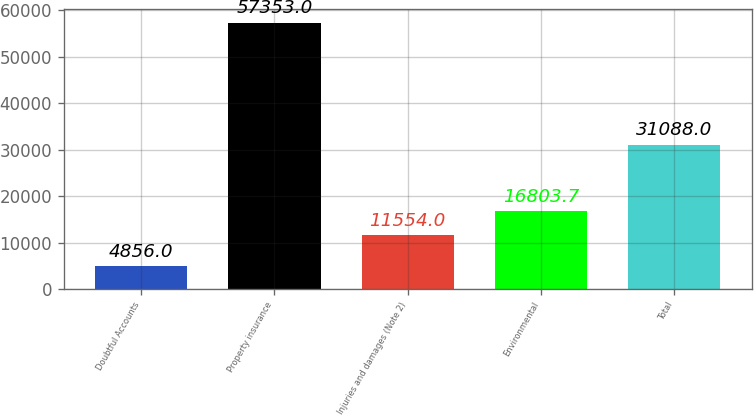Convert chart to OTSL. <chart><loc_0><loc_0><loc_500><loc_500><bar_chart><fcel>Doubtful Accounts<fcel>Property insurance<fcel>Injuries and damages (Note 2)<fcel>Environmental<fcel>Total<nl><fcel>4856<fcel>57353<fcel>11554<fcel>16803.7<fcel>31088<nl></chart> 